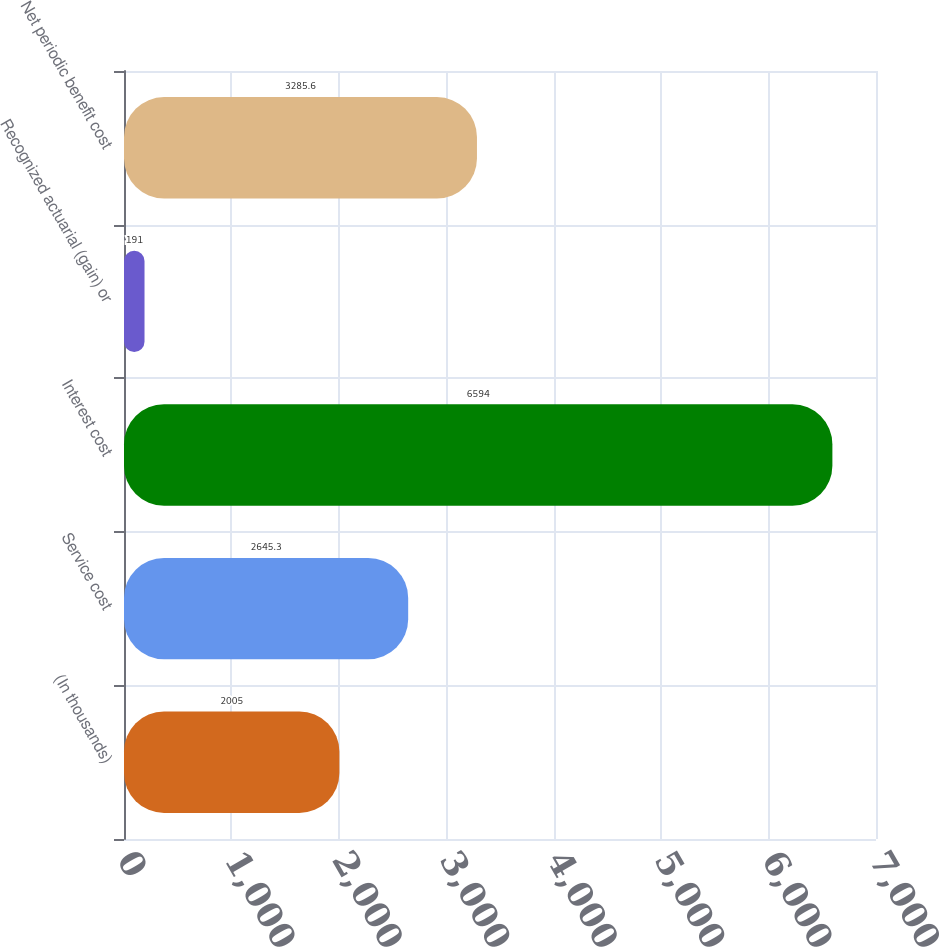<chart> <loc_0><loc_0><loc_500><loc_500><bar_chart><fcel>(In thousands)<fcel>Service cost<fcel>Interest cost<fcel>Recognized actuarial (gain) or<fcel>Net periodic benefit cost<nl><fcel>2005<fcel>2645.3<fcel>6594<fcel>191<fcel>3285.6<nl></chart> 